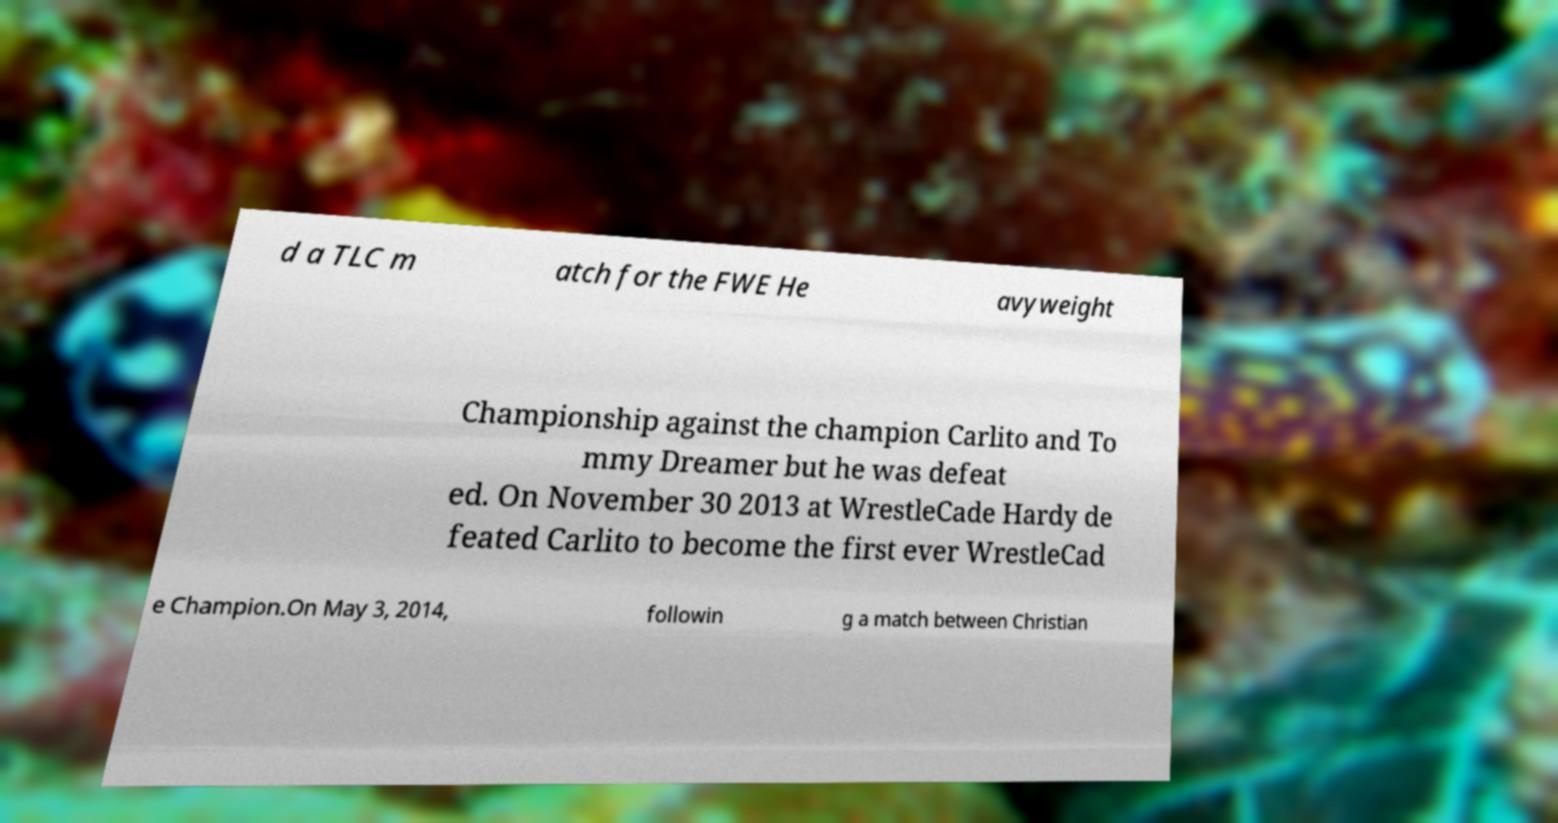Can you read and provide the text displayed in the image?This photo seems to have some interesting text. Can you extract and type it out for me? d a TLC m atch for the FWE He avyweight Championship against the champion Carlito and To mmy Dreamer but he was defeat ed. On November 30 2013 at WrestleCade Hardy de feated Carlito to become the first ever WrestleCad e Champion.On May 3, 2014, followin g a match between Christian 